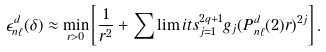<formula> <loc_0><loc_0><loc_500><loc_500>\epsilon _ { n \ell } ^ { d } ( \delta ) \approx \min _ { r > 0 } \left [ \frac { 1 } { r ^ { 2 } } + \sum \lim i t s _ { j = 1 } ^ { 2 q + 1 } g _ { j } ( P _ { n \ell } ^ { d } ( 2 ) r ) ^ { 2 j } \right ] .</formula> 